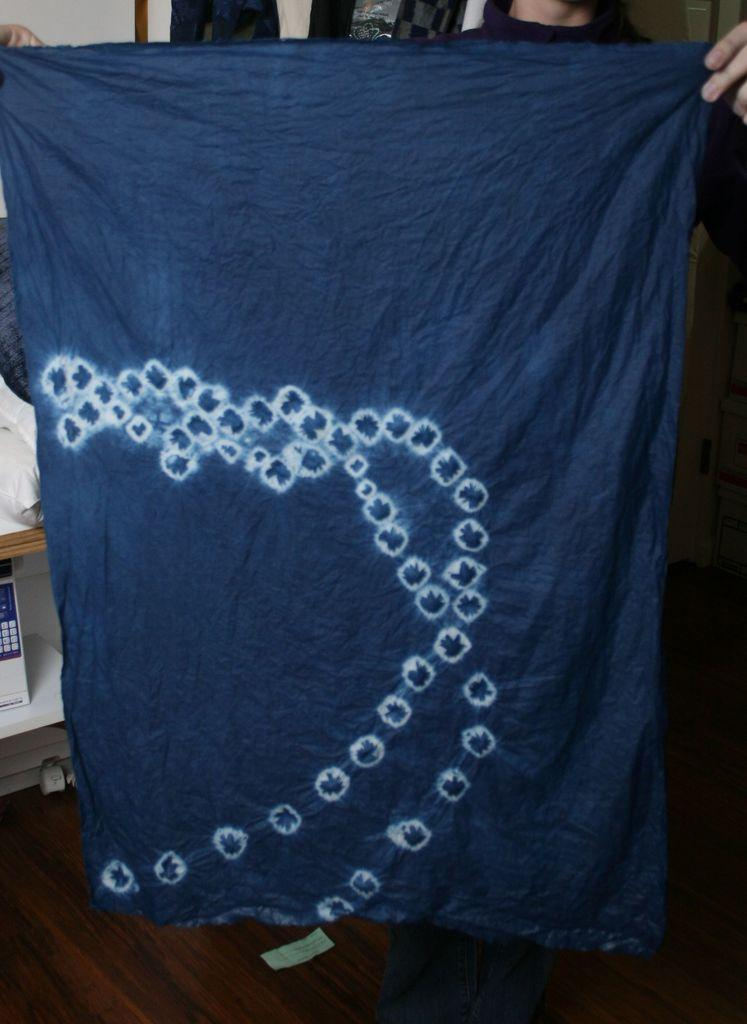What is the main subject of the image? There is a person in the image. What is the person holding in the image? The person is holding a violet color cloth. What is the person's posture in the image? The person is standing. What can be seen in the background of the image? There is a white wall in the background of the image. What type of quilt is the person using to cover the doctor in the image? There is no quilt or doctor present in the image. What type of education does the person in the image have? The provided facts do not give any information about the person's education. 